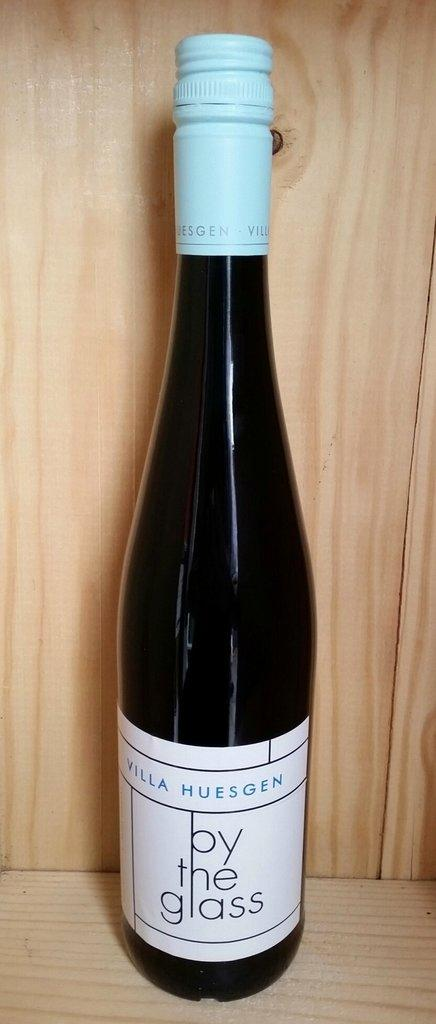<image>
Present a compact description of the photo's key features. A bottle o wine with by the glass on the label. 